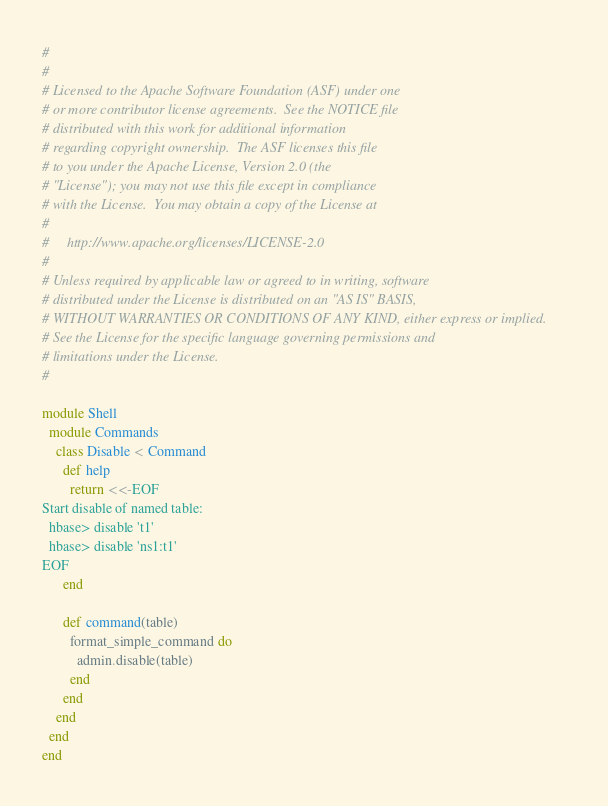Convert code to text. <code><loc_0><loc_0><loc_500><loc_500><_Ruby_>#
#
# Licensed to the Apache Software Foundation (ASF) under one
# or more contributor license agreements.  See the NOTICE file
# distributed with this work for additional information
# regarding copyright ownership.  The ASF licenses this file
# to you under the Apache License, Version 2.0 (the
# "License"); you may not use this file except in compliance
# with the License.  You may obtain a copy of the License at
#
#     http://www.apache.org/licenses/LICENSE-2.0
#
# Unless required by applicable law or agreed to in writing, software
# distributed under the License is distributed on an "AS IS" BASIS,
# WITHOUT WARRANTIES OR CONDITIONS OF ANY KIND, either express or implied.
# See the License for the specific language governing permissions and
# limitations under the License.
#

module Shell
  module Commands
    class Disable < Command
      def help
        return <<-EOF
Start disable of named table:
  hbase> disable 't1'
  hbase> disable 'ns1:t1'
EOF
      end

      def command(table)
        format_simple_command do
          admin.disable(table)
        end
      end
    end
  end
end
</code> 